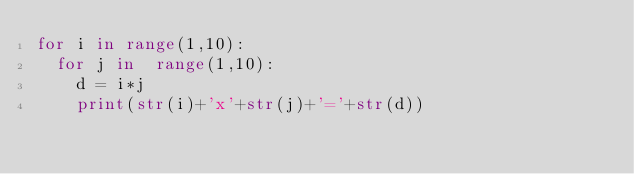<code> <loc_0><loc_0><loc_500><loc_500><_Python_>for i in range(1,10):
  for j in  range(1,10):
    d = i*j
    print(str(i)+'x'+str(j)+'='+str(d))
</code> 